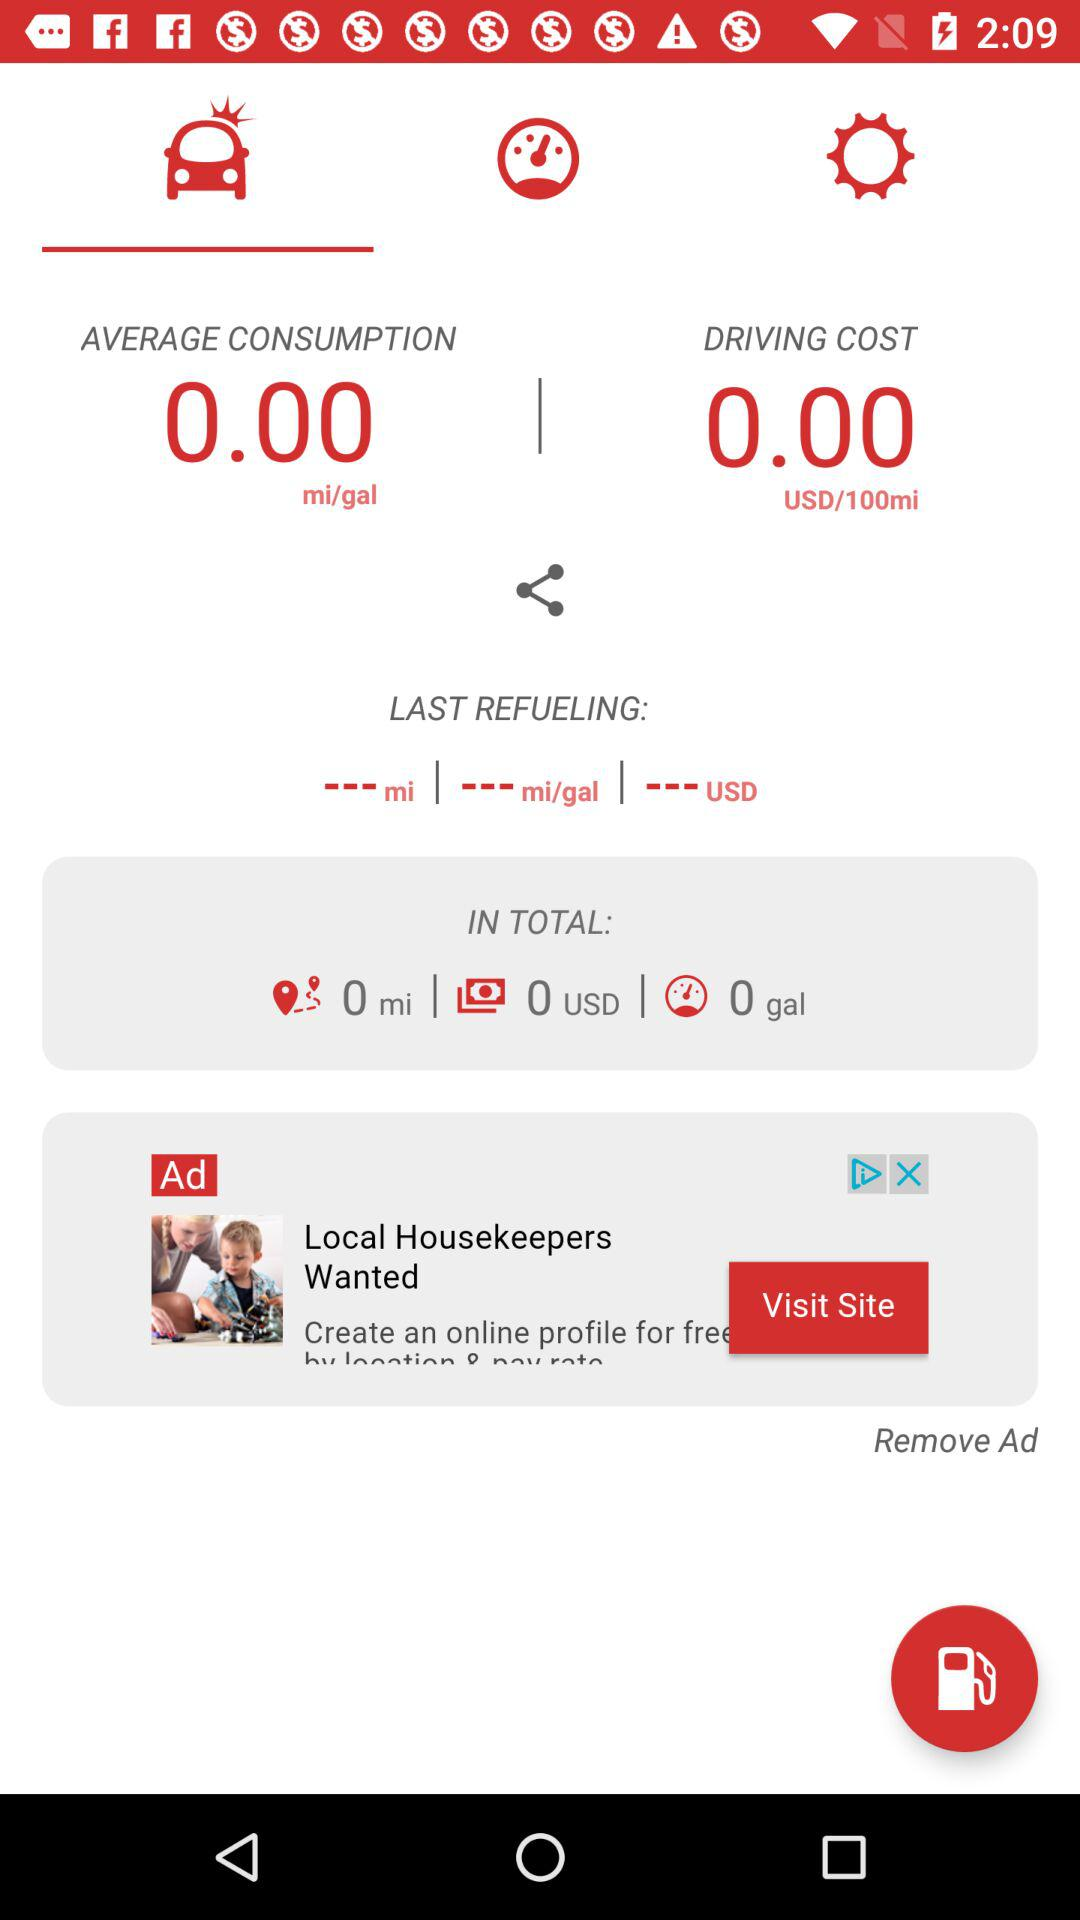What currency is shown for making the payment? The currency shown for making the payment is the USD. 